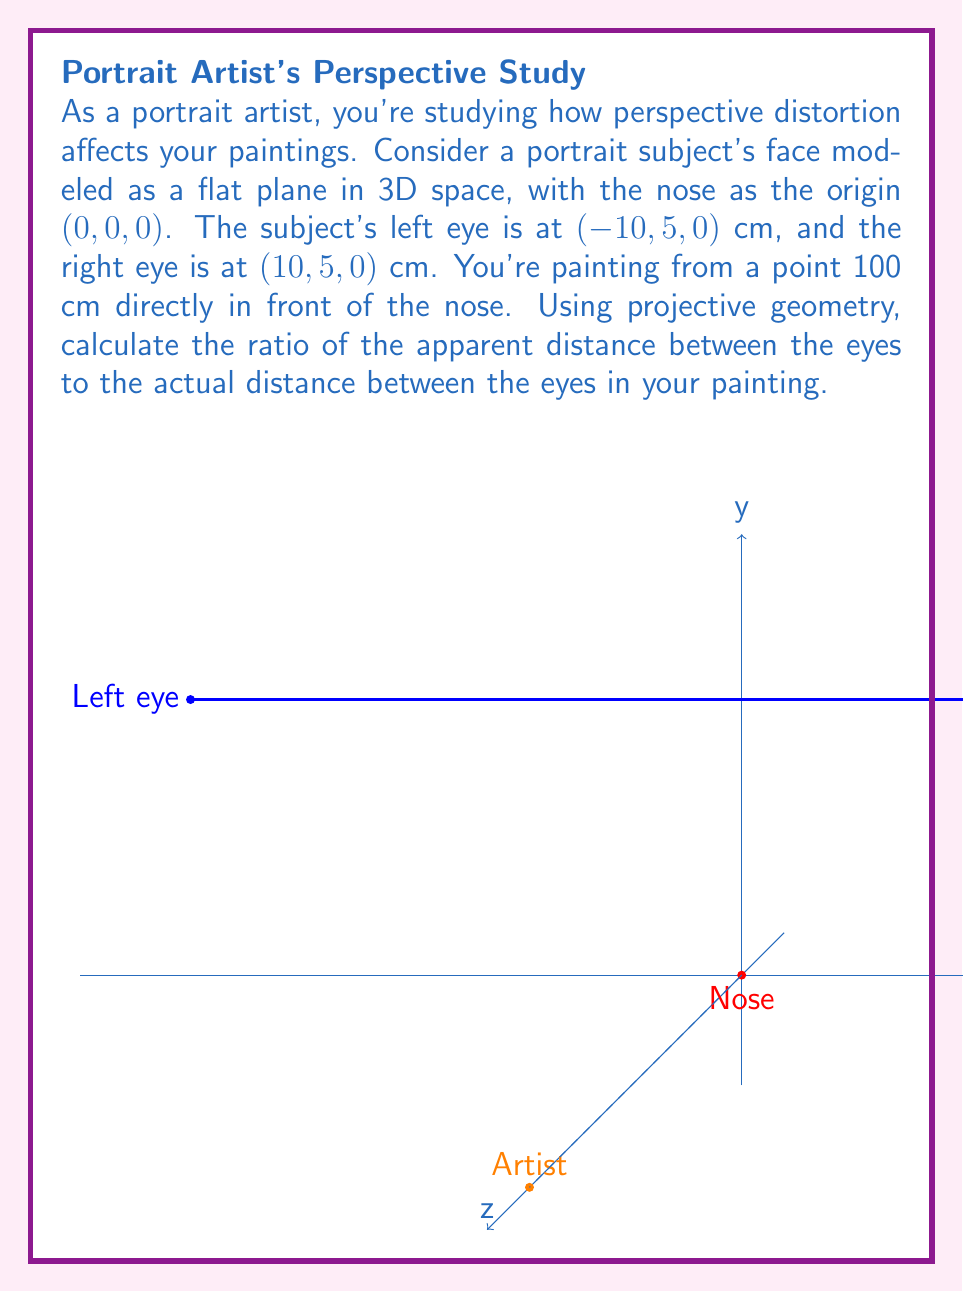What is the answer to this math problem? Let's approach this step-by-step using projective geometry:

1) In projective geometry, we use homogeneous coordinates. Let's convert our Euclidean coordinates to homogeneous coordinates by adding a 1 as the fourth component:
   Left eye: $(-10, 5, 0, 1)$
   Right eye: $(10, 5, 0, 1)$
   Camera position: $(100, 0, 0, 1)$

2) The projection matrix for a camera at $(100, 0, 0)$ looking towards the origin is:

   $$P = \begin{bmatrix}
   1 & 0 & 0 & -100 \\
   0 & 1 & 0 & 0 \\
   0 & 0 & 1 & 0 \\
   0 & 0 & \frac{1}{100} & 0
   \end{bmatrix}$$

3) Let's project the left eye:
   $P \cdot (-10, 5, 0, 1)^T = (-110, 5, 0, -0.1)^T$

4) And the right eye:
   $P \cdot (10, 5, 0, 1)^T = (-90, 5, 0, 0.1)^T$

5) To get back to Euclidean coordinates, we divide by the last component:
   Left eye projected: $(-1100, -50, 0)$
   Right eye projected: $(-900, 50, 0)$

6) The apparent distance between the eyes is the distance between these projected points:
   $\sqrt{(-900 - (-1100))^2 + (50 - (-50))^2} = \sqrt{200^2 + 100^2} = \sqrt{50000} = 10\sqrt{500}$

7) The actual distance between the eyes is:
   $\sqrt{(10 - (-10))^2 + (5 - 5)^2} = 20$

8) The ratio of apparent distance to actual distance is:
   $\frac{10\sqrt{500}}{20} = \frac{\sqrt{500}}{2}$
Answer: $\frac{\sqrt{500}}{2}$ 